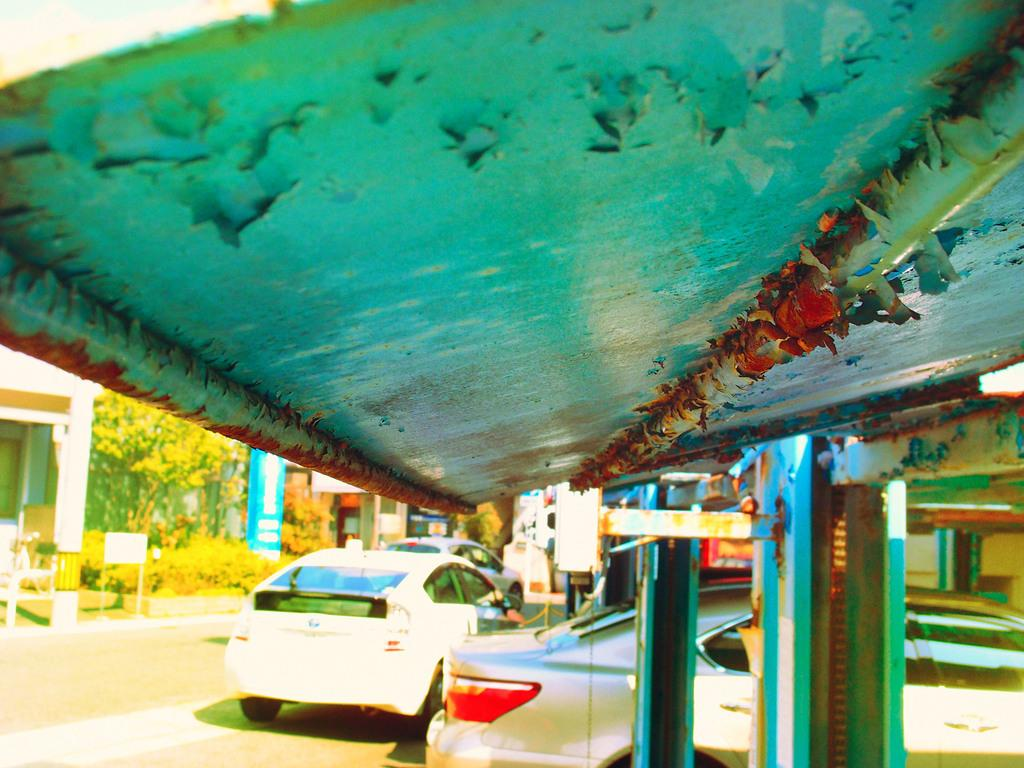What type of structures can be seen in the image? There are buildings in the image. What natural elements are present in the image? There are trees and plants in the image. What man-made objects can be seen in the image? There are cars and a board on the sidewalk in the image. What is the opinion of the prison on the leather sofa in the image? There is no prison or leather sofa present in the image. 